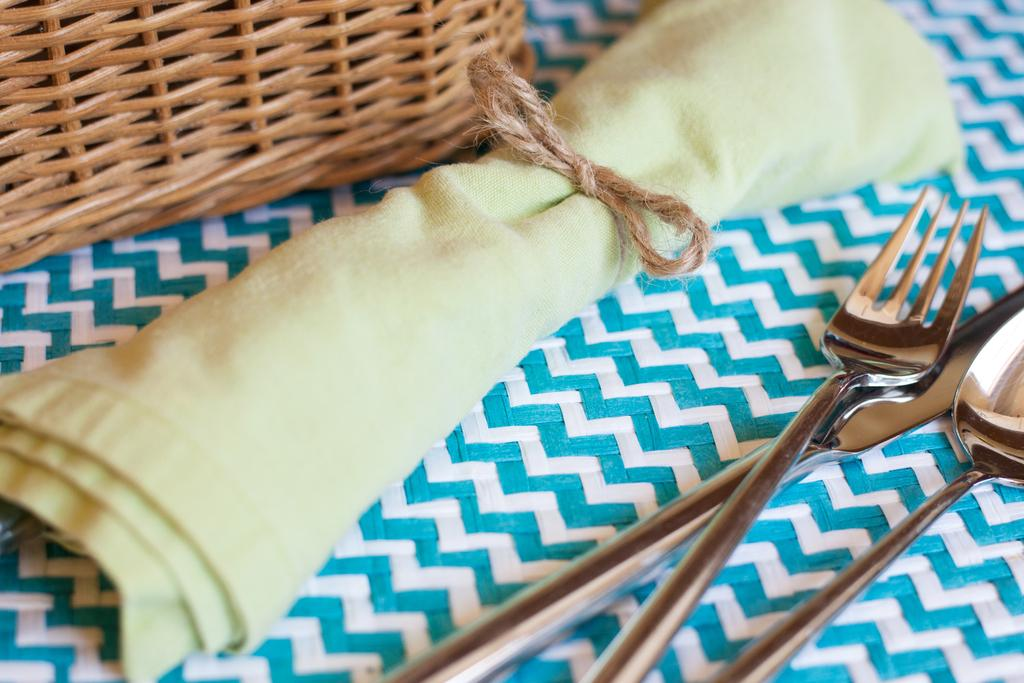What utensils can be seen in the image? There are spoons in the image. What is on the table in the image? There is a bowl on the table in the image. What color is the object in the image? There is a green object in the image. What container is present in the image? There is a basket in the image. Can you see the smile on the green object in the image? There is no smile present on the green object in the image, as it is an inanimate object and not capable of expressing emotions. 